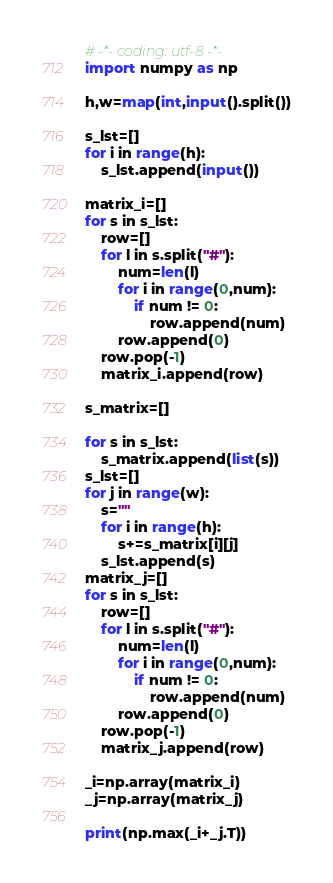<code> <loc_0><loc_0><loc_500><loc_500><_Python_># -*- coding: utf-8 -*-
import numpy as np

h,w=map(int,input().split())

s_lst=[]
for i in range(h):
    s_lst.append(input())
    
matrix_i=[]
for s in s_lst:
    row=[]
    for l in s.split("#"):
        num=len(l)
        for i in range(0,num):
            if num != 0:
                row.append(num)
        row.append(0)
    row.pop(-1)
    matrix_i.append(row)

s_matrix=[]

for s in s_lst:
    s_matrix.append(list(s))
s_lst=[]
for j in range(w):
    s=""
    for i in range(h):
        s+=s_matrix[i][j]
    s_lst.append(s)
matrix_j=[]
for s in s_lst:
    row=[]
    for l in s.split("#"):
        num=len(l)
        for i in range(0,num):
            if num != 0:
                row.append(num)
        row.append(0)
    row.pop(-1)
    matrix_j.append(row)
    
_i=np.array(matrix_i)
_j=np.array(matrix_j)

print(np.max(_i+_j.T))</code> 